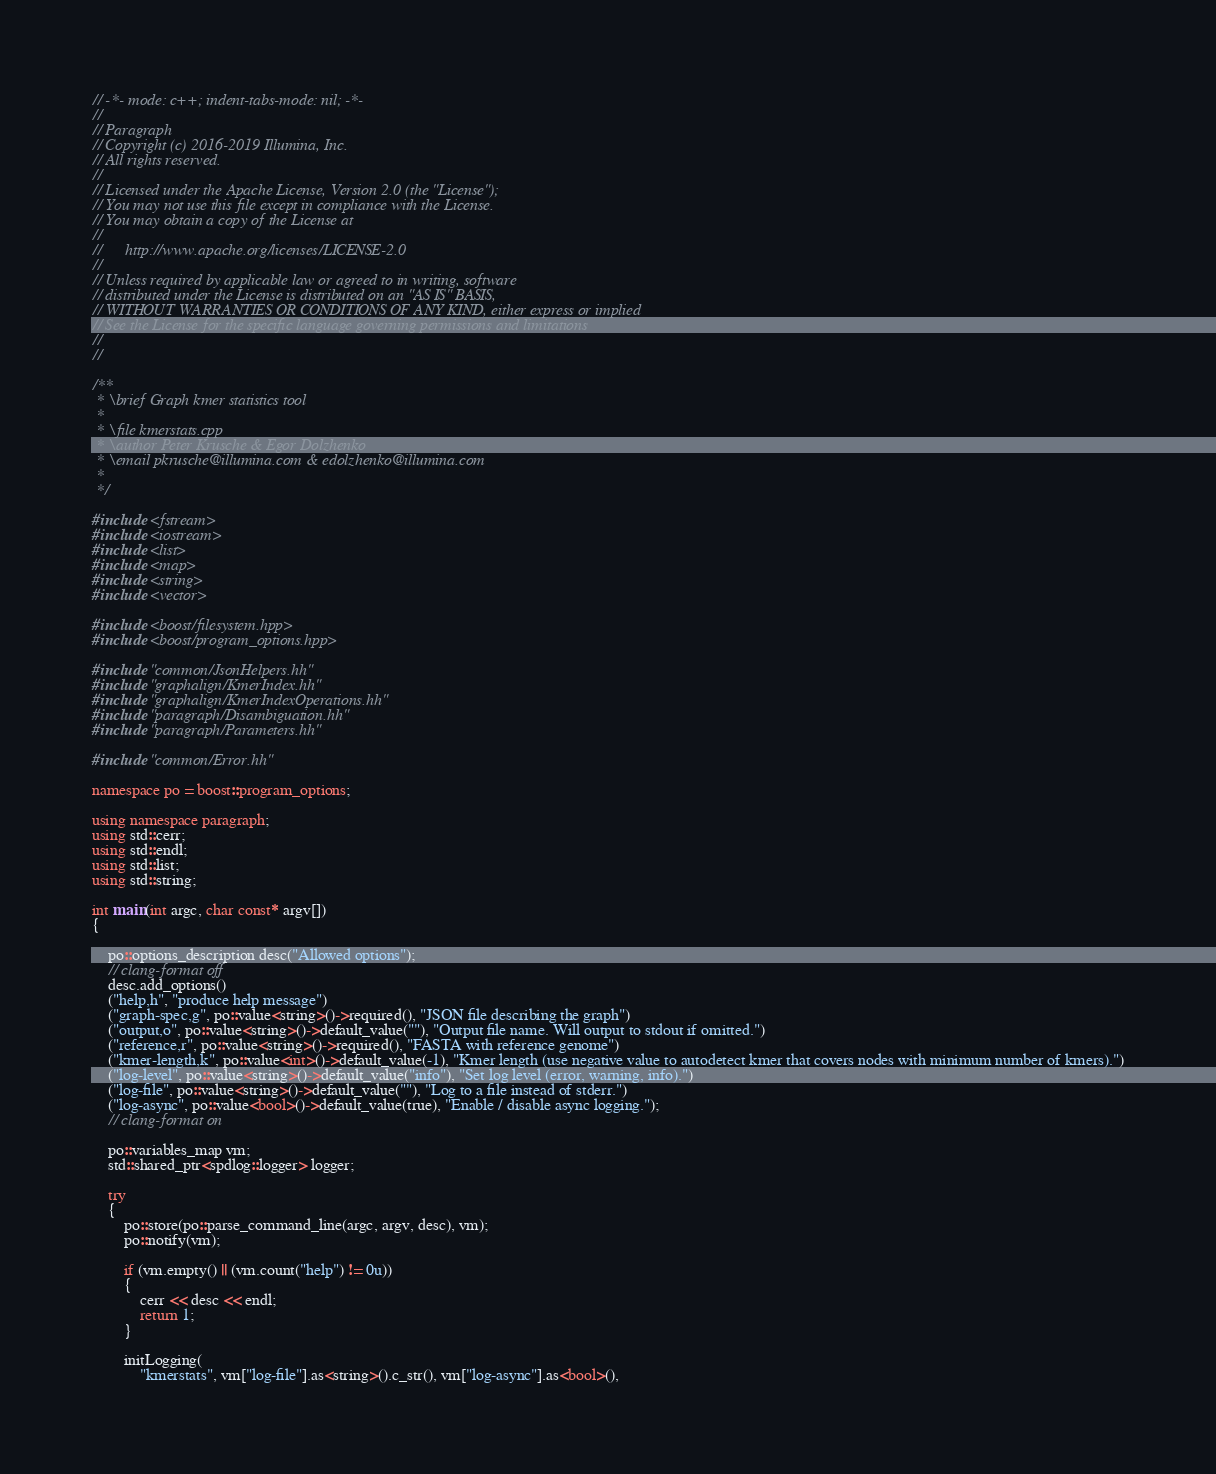<code> <loc_0><loc_0><loc_500><loc_500><_C++_>// -*- mode: c++; indent-tabs-mode: nil; -*-
//
// Paragraph
// Copyright (c) 2016-2019 Illumina, Inc.
// All rights reserved.
//
// Licensed under the Apache License, Version 2.0 (the "License");
// You may not use this file except in compliance with the License.
// You may obtain a copy of the License at
//
//		http://www.apache.org/licenses/LICENSE-2.0
//
// Unless required by applicable law or agreed to in writing, software
// distributed under the License is distributed on an "AS IS" BASIS,
// WITHOUT WARRANTIES OR CONDITIONS OF ANY KIND, either express or implied
// See the License for the specific language governing permissions and limitations
//
//

/**
 * \brief Graph kmer statistics tool
 *
 * \file kmerstats.cpp
 * \author Peter Krusche & Egor Dolzhenko
 * \email pkrusche@illumina.com & edolzhenko@illumina.com
 *
 */

#include <fstream>
#include <iostream>
#include <list>
#include <map>
#include <string>
#include <vector>

#include <boost/filesystem.hpp>
#include <boost/program_options.hpp>

#include "common/JsonHelpers.hh"
#include "graphalign/KmerIndex.hh"
#include "graphalign/KmerIndexOperations.hh"
#include "paragraph/Disambiguation.hh"
#include "paragraph/Parameters.hh"

#include "common/Error.hh"

namespace po = boost::program_options;

using namespace paragraph;
using std::cerr;
using std::endl;
using std::list;
using std::string;

int main(int argc, char const* argv[])
{

    po::options_description desc("Allowed options");
    // clang-format off
    desc.add_options()
    ("help,h", "produce help message")
    ("graph-spec,g", po::value<string>()->required(), "JSON file describing the graph")
    ("output,o", po::value<string>()->default_value(""), "Output file name. Will output to stdout if omitted.")
    ("reference,r", po::value<string>()->required(), "FASTA with reference genome")
    ("kmer-length,k", po::value<int>()->default_value(-1), "Kmer length (use negative value to autodetect kmer that covers nodes with minimum number of kmers).")
    ("log-level", po::value<string>()->default_value("info"), "Set log level (error, warning, info).")
    ("log-file", po::value<string>()->default_value(""), "Log to a file instead of stderr.")
    ("log-async", po::value<bool>()->default_value(true), "Enable / disable async logging.");
    // clang-format on

    po::variables_map vm;
    std::shared_ptr<spdlog::logger> logger;

    try
    {
        po::store(po::parse_command_line(argc, argv, desc), vm);
        po::notify(vm);

        if (vm.empty() || (vm.count("help") != 0u))
        {
            cerr << desc << endl;
            return 1;
        }

        initLogging(
            "kmerstats", vm["log-file"].as<string>().c_str(), vm["log-async"].as<bool>(),</code> 